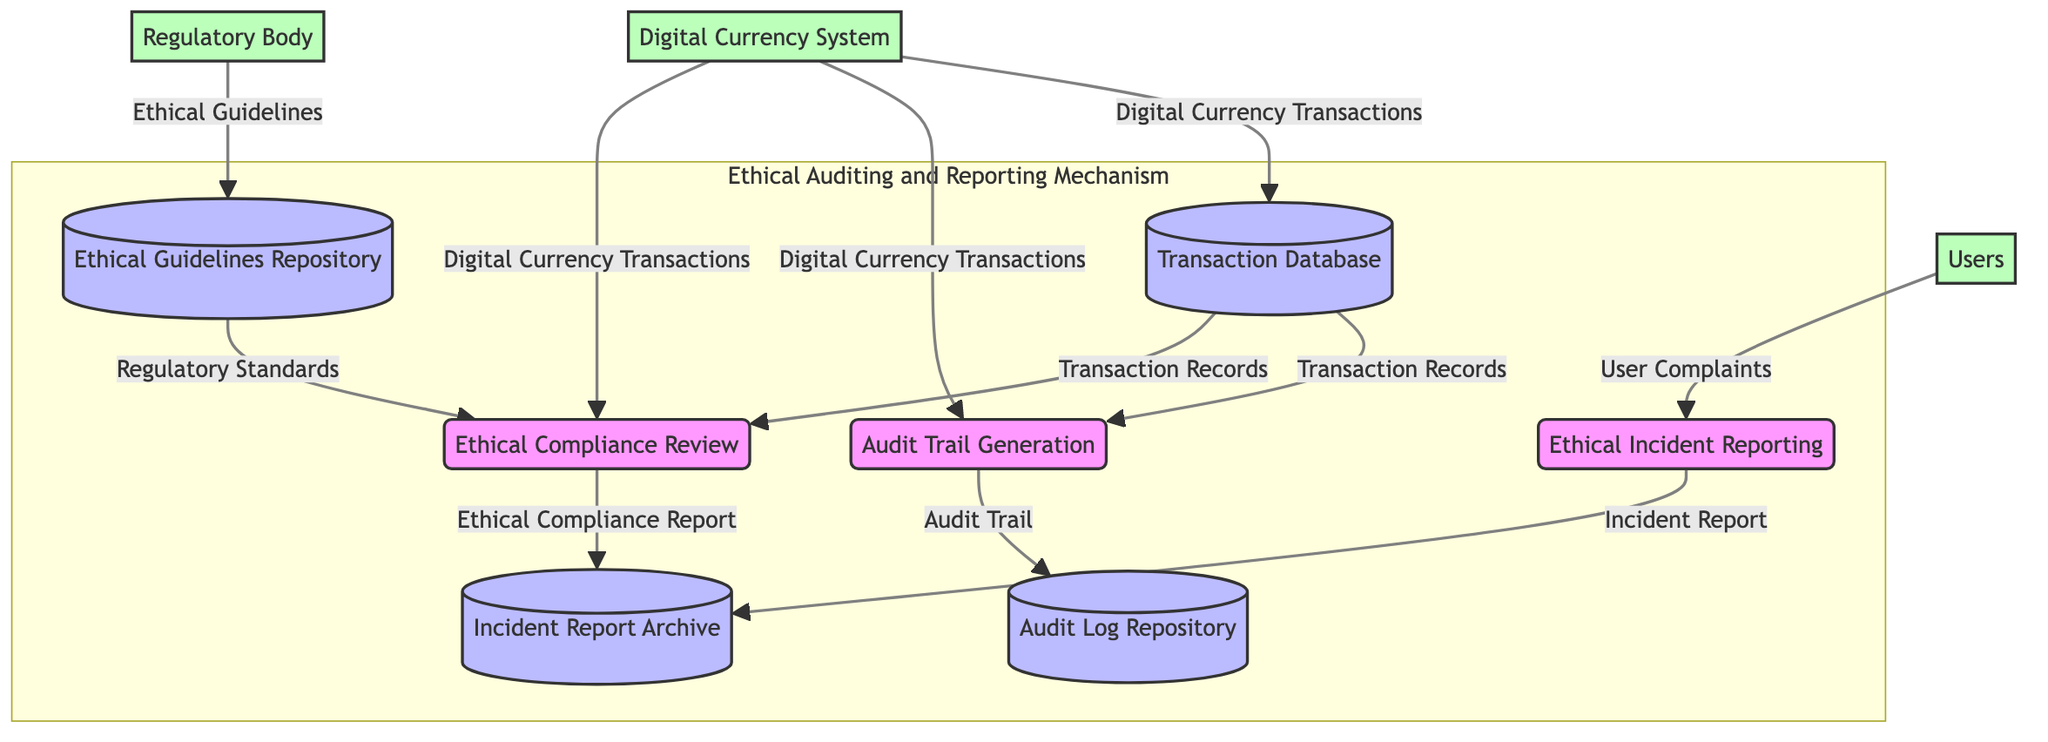What is the name of the process that generates audit trails? The diagram shows that the process responsible for generating audit trails is labeled "Audit Trail Generation."
Answer: Audit Trail Generation How many data stores are present in this diagram? By counting the labeled data stores in the diagram, there are four data stores: Transaction Database, Ethical Guidelines Repository, Incident Report Archive, and Audit Log Repository.
Answer: 4 What type of data is supplied to the "Ethical Compliance Review" process from the "Ethical Guidelines Repository"? The flow from the "Ethical Guidelines Repository" to the "Ethical Compliance Review" process indicates the data type as "Regulatory Standards."
Answer: Regulatory Standards Which external entity provides user complaints to the "Ethical Incident Reporting" process? The diagram indicates that users are the external entity that supplies user complaints to the "Ethical Incident Reporting" process.
Answer: Users What is the output of the "Ethical Incident Reporting" process? The diagram specifies that the "Ethical Incident Reporting" process produces an output labeled "Incident Report."
Answer: Incident Report Which data store receives the output from both the "Ethical Compliance Review" and "Ethical Incident Reporting" processes? The "Incident Report Archive" is the data store that collects outputs from both the "Ethical Compliance Review" (Ethical Compliance Report) and "Ethical Incident Reporting" (Incident Report) processes.
Answer: Incident Report Archive What inputs are required for the "Audit Trail Generation" process? According to the diagram, the "Audit Trail Generation" process requires "Digital Currency Transactions" as its input.
Answer: Digital Currency Transactions What data is transferred from the "Audit Trail Generation" to the "Audit Log Repository"? The data flow indicates that the output from the "Audit Trail Generation" process transferred to the "Audit Log Repository" is called "Audit Trail."
Answer: Audit Trail 